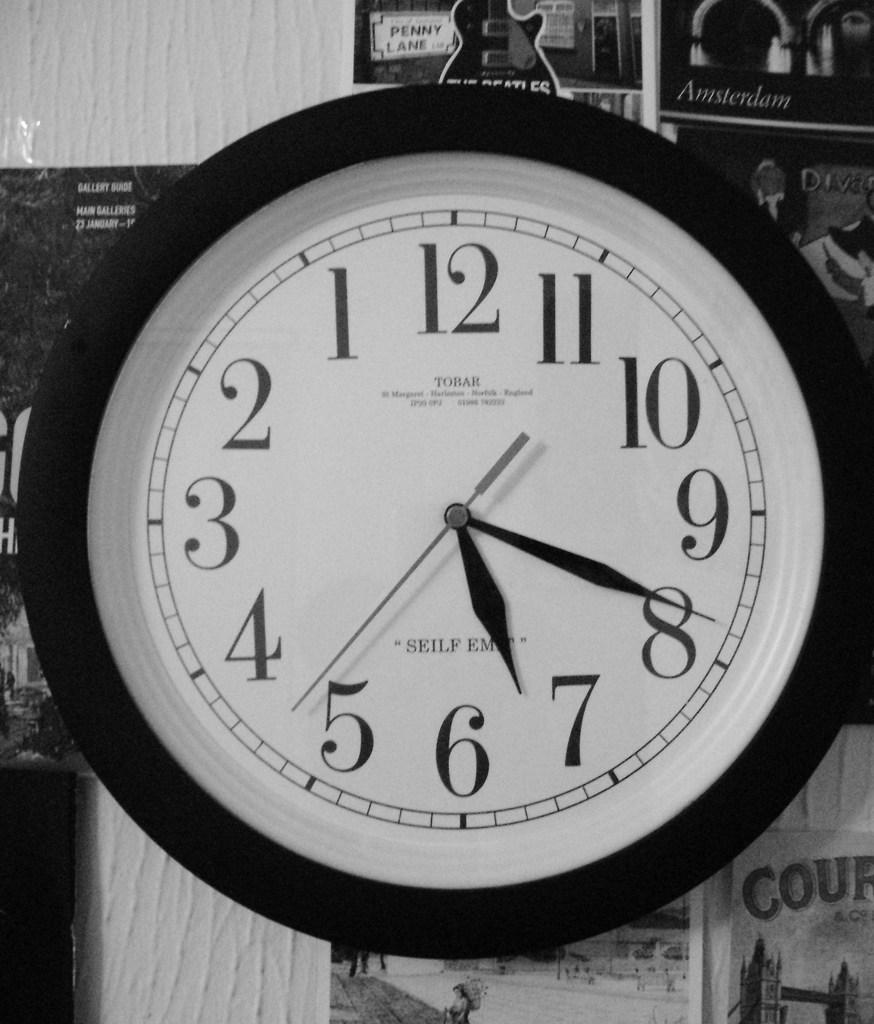<image>
Describe the image concisely. Mirror image of a black and white circular clock showing the time as 6:41:23. 